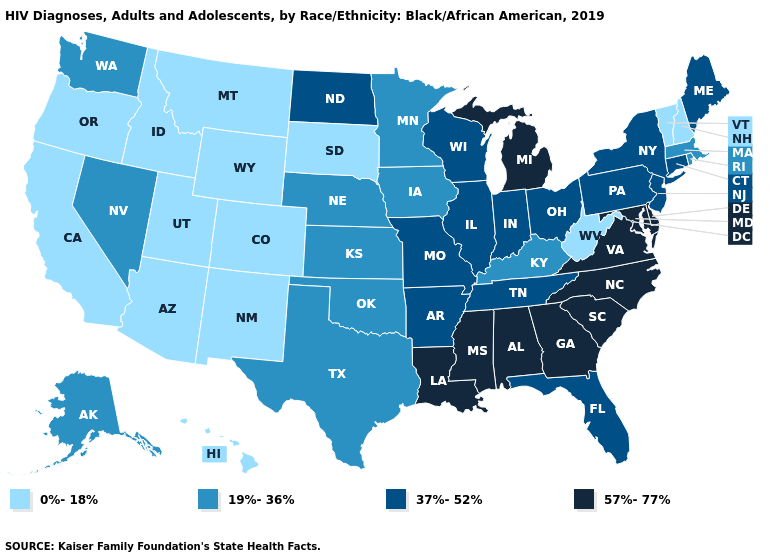Does Louisiana have the highest value in the USA?
Keep it brief. Yes. Does the map have missing data?
Give a very brief answer. No. What is the lowest value in states that border Indiana?
Give a very brief answer. 19%-36%. What is the value of Maryland?
Write a very short answer. 57%-77%. Name the states that have a value in the range 0%-18%?
Write a very short answer. Arizona, California, Colorado, Hawaii, Idaho, Montana, New Hampshire, New Mexico, Oregon, South Dakota, Utah, Vermont, West Virginia, Wyoming. What is the value of Mississippi?
Quick response, please. 57%-77%. Does New Jersey have the same value as New Mexico?
Concise answer only. No. Does Oklahoma have the highest value in the South?
Concise answer only. No. Does Texas have the highest value in the South?
Short answer required. No. Name the states that have a value in the range 37%-52%?
Be succinct. Arkansas, Connecticut, Florida, Illinois, Indiana, Maine, Missouri, New Jersey, New York, North Dakota, Ohio, Pennsylvania, Tennessee, Wisconsin. Among the states that border Nebraska , does Wyoming have the lowest value?
Keep it brief. Yes. Among the states that border Delaware , which have the lowest value?
Quick response, please. New Jersey, Pennsylvania. Does Missouri have the highest value in the USA?
Concise answer only. No. What is the lowest value in the USA?
Write a very short answer. 0%-18%. Does the first symbol in the legend represent the smallest category?
Quick response, please. Yes. 